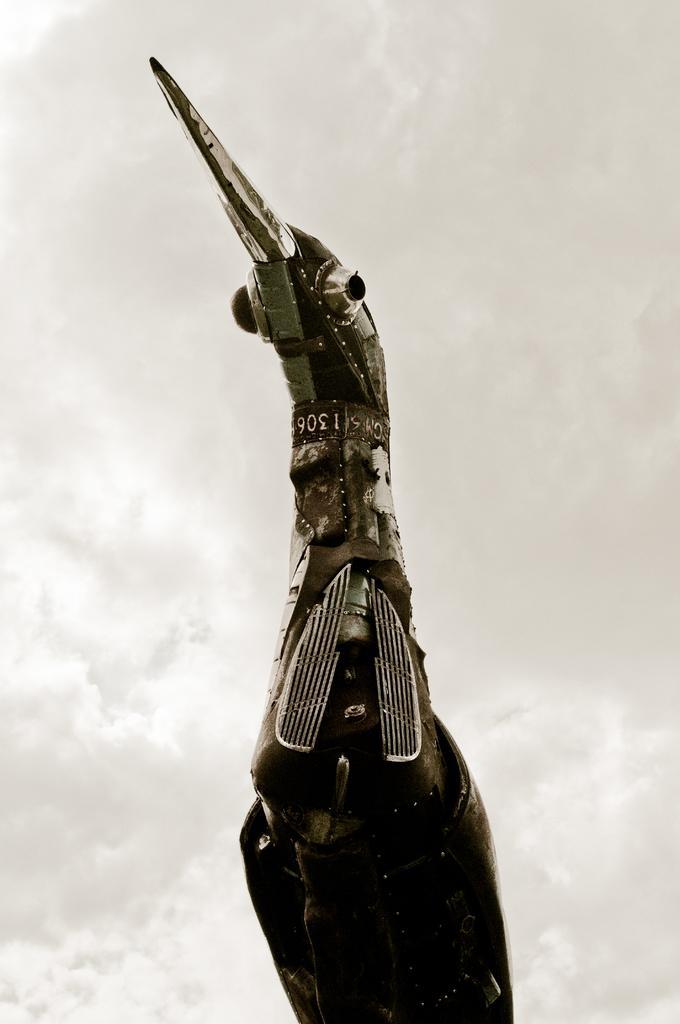Can you describe this image briefly? In the center of the image we can see one bird architecture and we can see some text on it. In the background we can see the sky and clouds. 